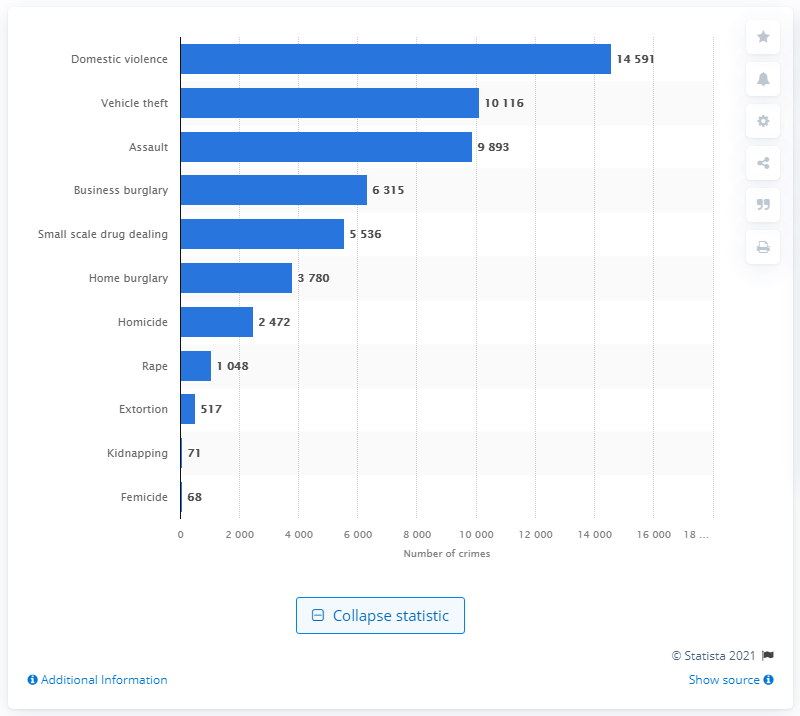Mention a couple of crucial points in this snapshot. In April 2020, there were 14591 reported cases of domestic violence. 